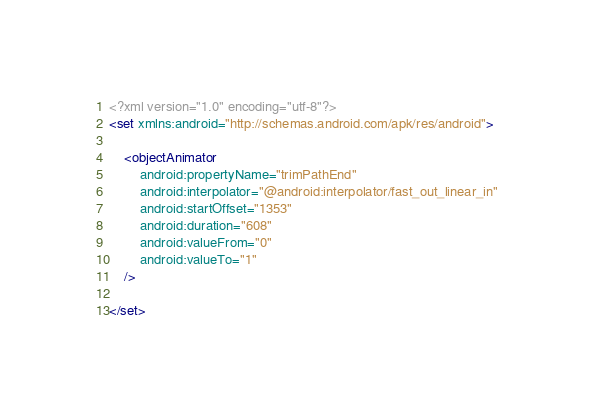<code> <loc_0><loc_0><loc_500><loc_500><_XML_><?xml version="1.0" encoding="utf-8"?>
<set xmlns:android="http://schemas.android.com/apk/res/android">

    <objectAnimator
        android:propertyName="trimPathEnd"
        android:interpolator="@android:interpolator/fast_out_linear_in"
        android:startOffset="1353"
        android:duration="608"
        android:valueFrom="0"
        android:valueTo="1"
    />

</set></code> 